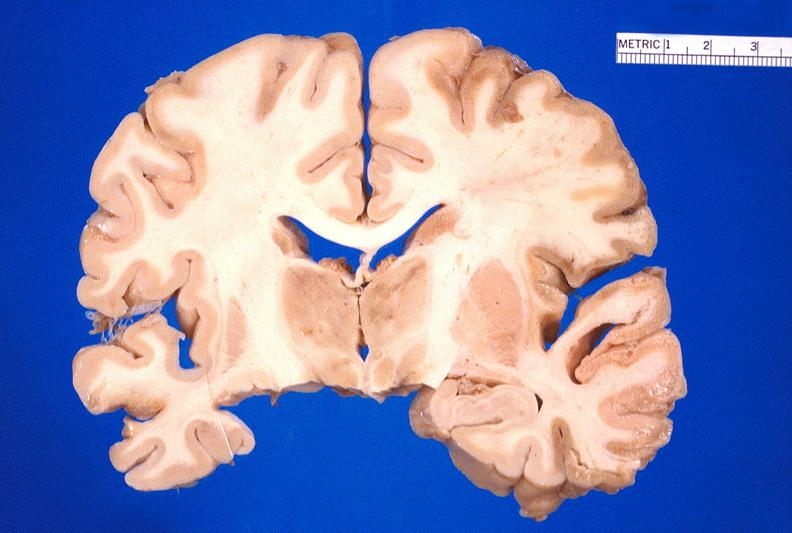s wonder present?
Answer the question using a single word or phrase. No 